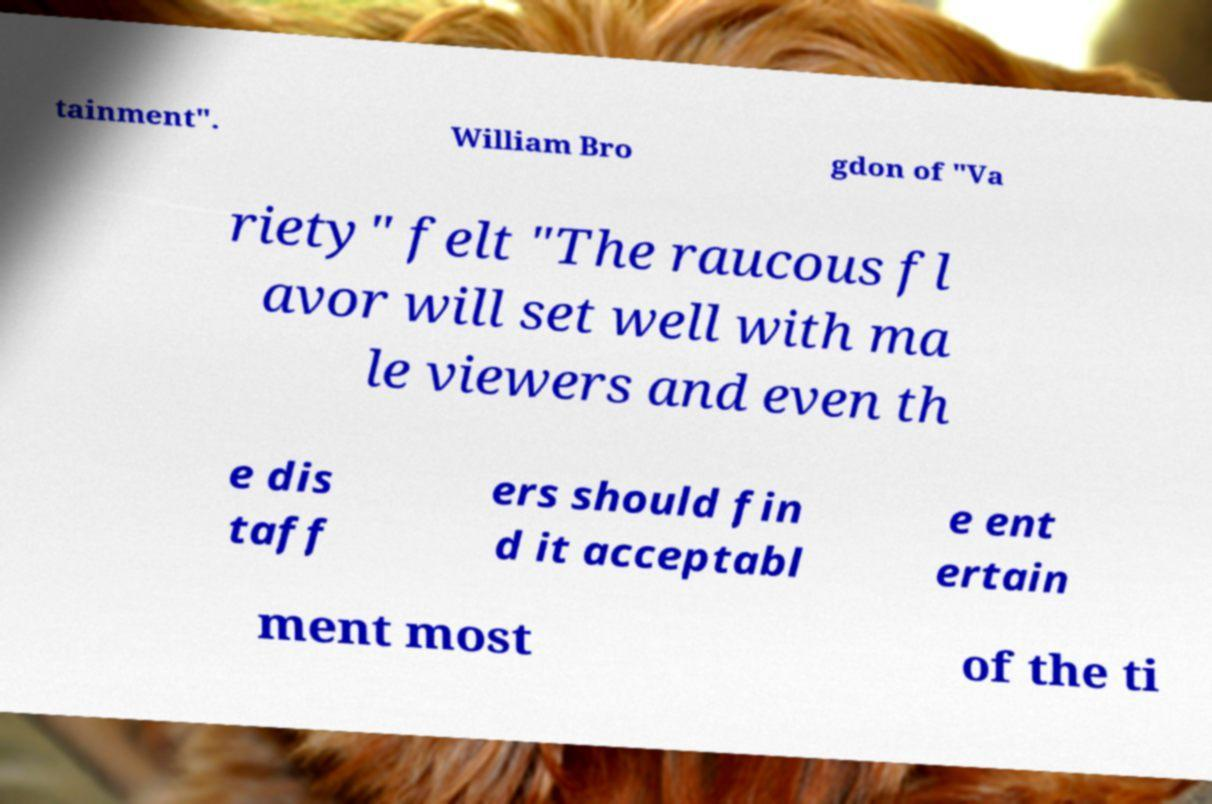What messages or text are displayed in this image? I need them in a readable, typed format. tainment". William Bro gdon of "Va riety" felt "The raucous fl avor will set well with ma le viewers and even th e dis taff ers should fin d it acceptabl e ent ertain ment most of the ti 